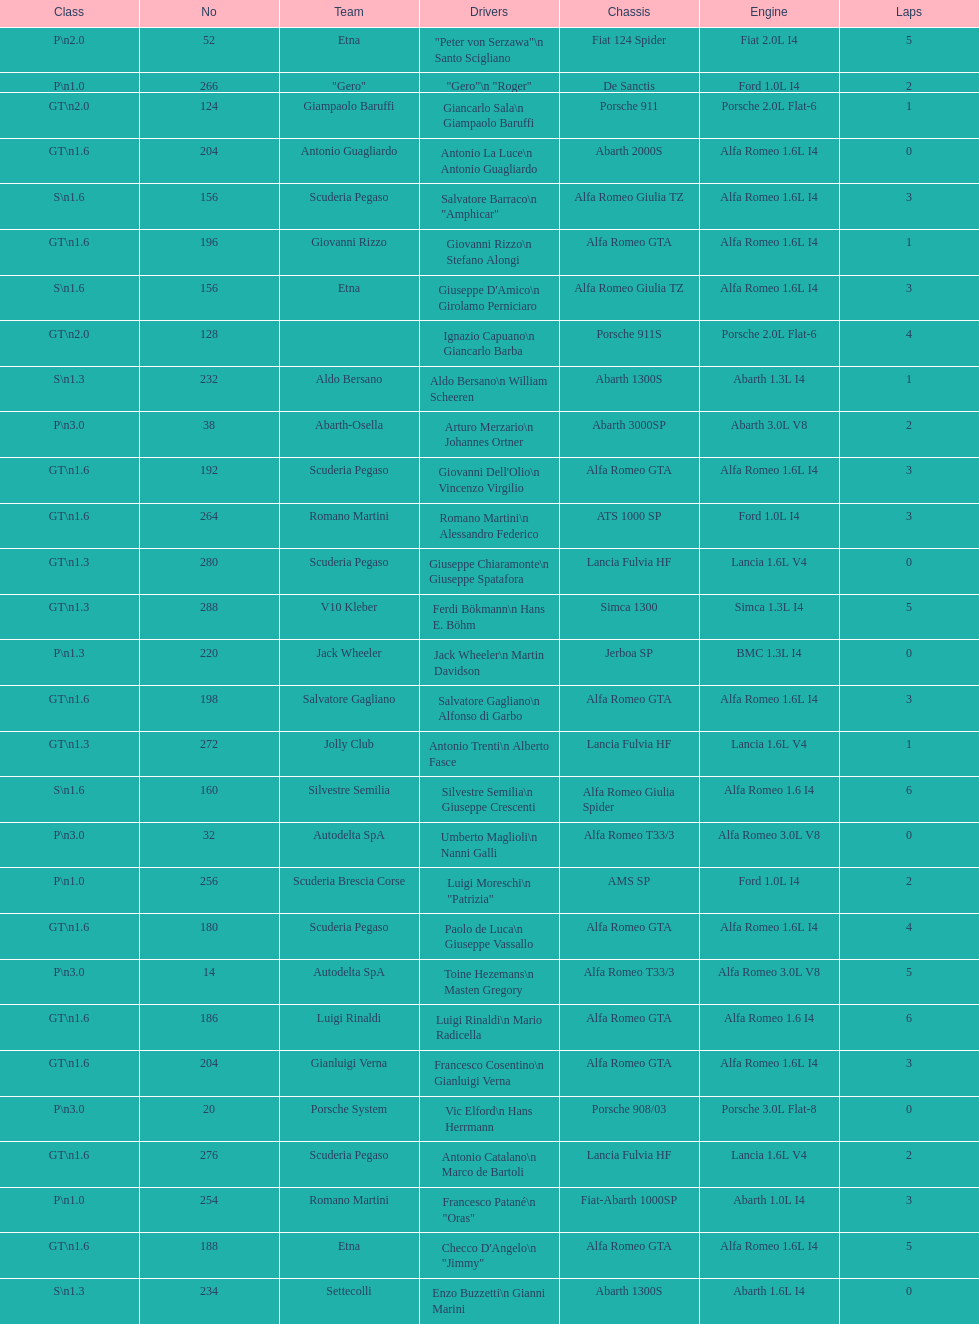Name the only american who did not finish the race. Masten Gregory. 